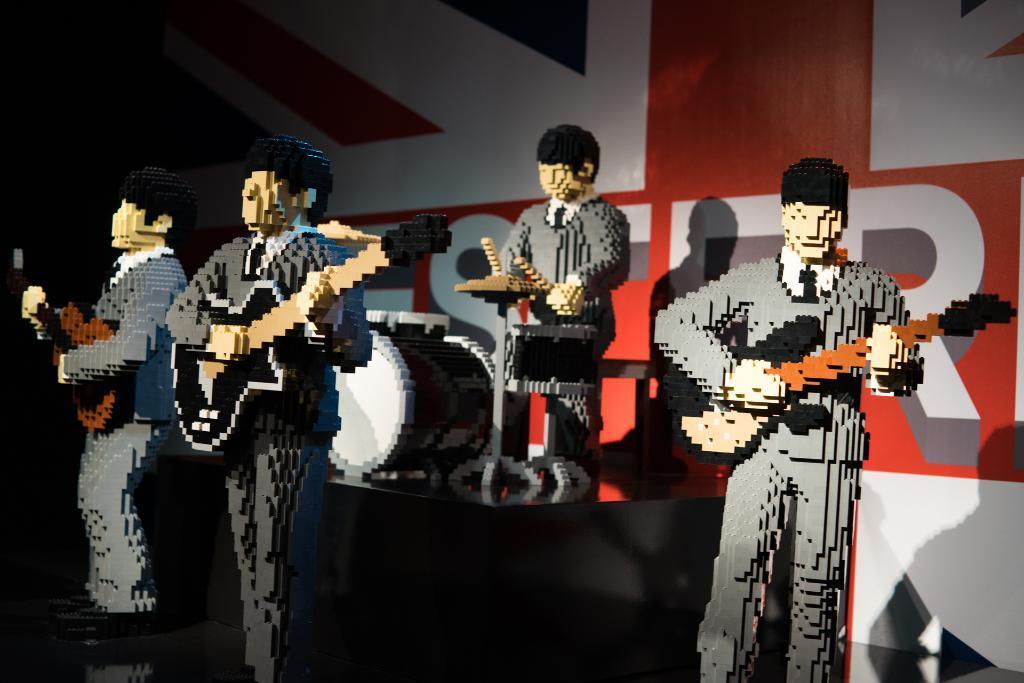How would you summarize this image in a sentence or two? This picture shows cartoons playing musical instruments. Few are playing guitars and another one is playing drums. 